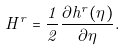<formula> <loc_0><loc_0><loc_500><loc_500>H ^ { r } = \frac { 1 } { 2 } \frac { \partial h ^ { r } ( \eta ) } { \partial \eta } .</formula> 